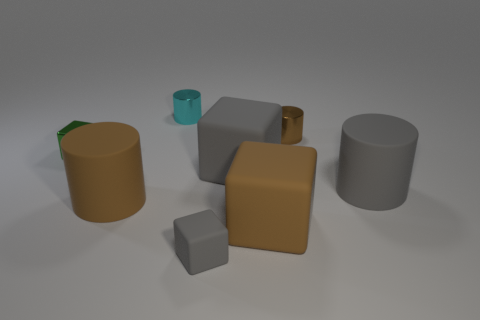Add 1 small gray cubes. How many objects exist? 9 Subtract all large gray rubber cylinders. How many cylinders are left? 3 Subtract 1 cubes. How many cubes are left? 3 Subtract all cyan cylinders. How many cylinders are left? 3 Subtract all yellow blocks. Subtract all cyan spheres. How many blocks are left? 4 Subtract 0 yellow cubes. How many objects are left? 8 Subtract all red cylinders. How many brown blocks are left? 1 Subtract all tiny green things. Subtract all gray objects. How many objects are left? 4 Add 2 small gray things. How many small gray things are left? 3 Add 8 big blue things. How many big blue things exist? 8 